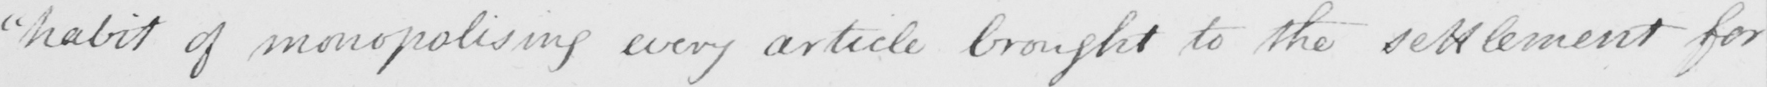What is written in this line of handwriting? " habit of monopolising every article brought to the settlement for 